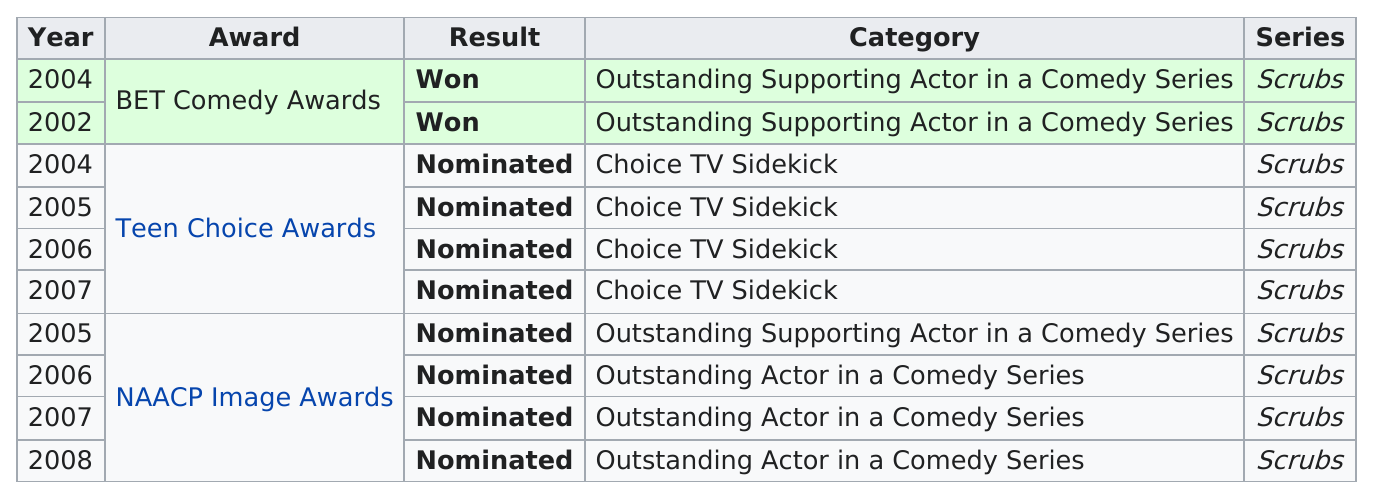Indicate a few pertinent items in this graphic. Scrubs won the most Outstanding Supporting Actor in a Comedy Series awards. The BET Comedy Awards was the only award that Scrubs won for Outstanding Supporting Actor in a Comedy Series. In 2002, Scrubs won the BET Comedy Awards. The committee received a total of 10 nominations. Scrubs was nominated for four Teen Choice Awards from 2004 to 2007. 